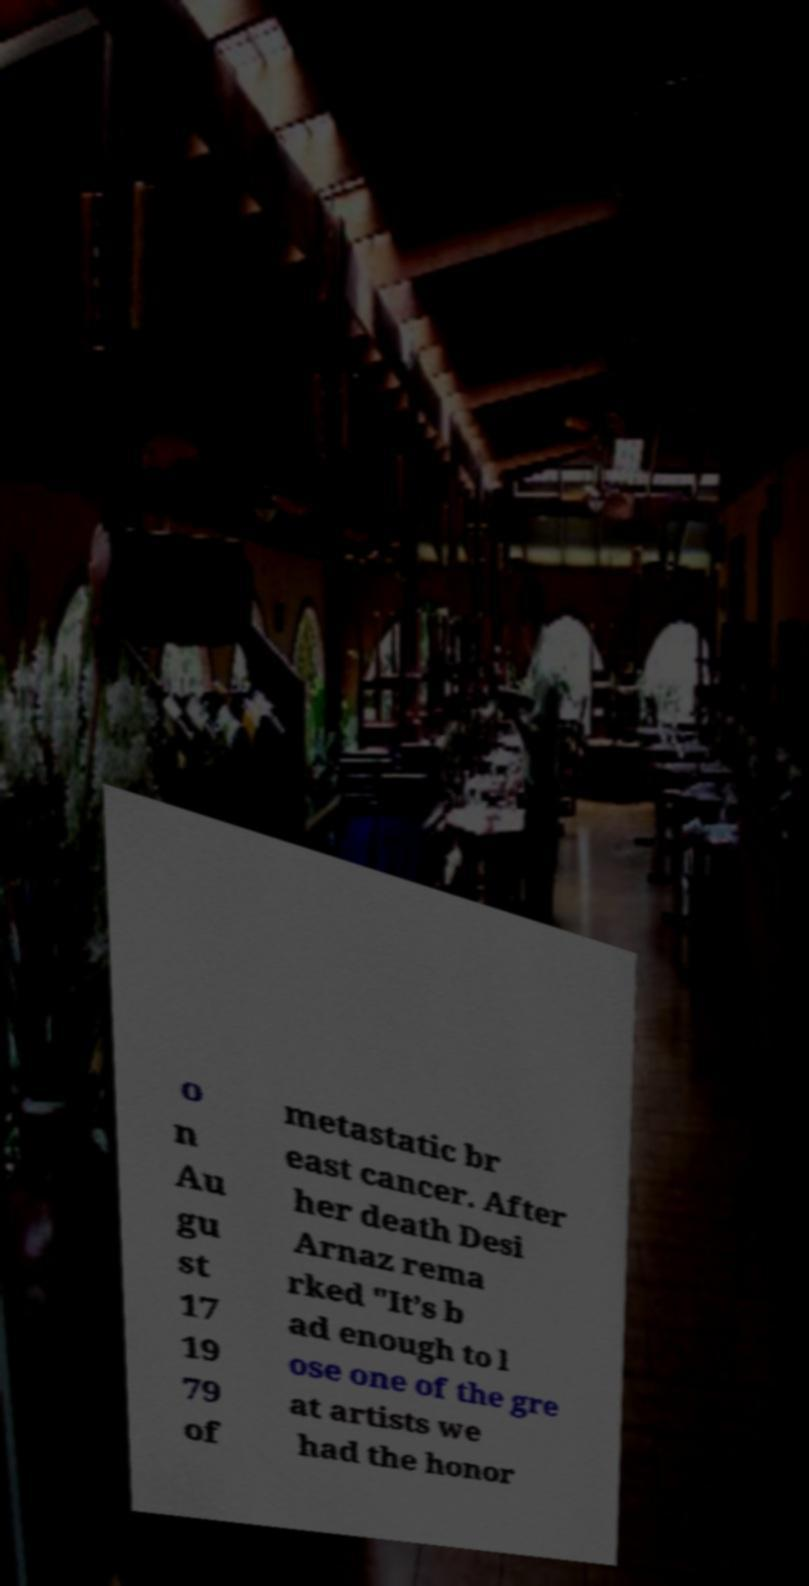Please read and relay the text visible in this image. What does it say? o n Au gu st 17 19 79 of metastatic br east cancer. After her death Desi Arnaz rema rked "It’s b ad enough to l ose one of the gre at artists we had the honor 